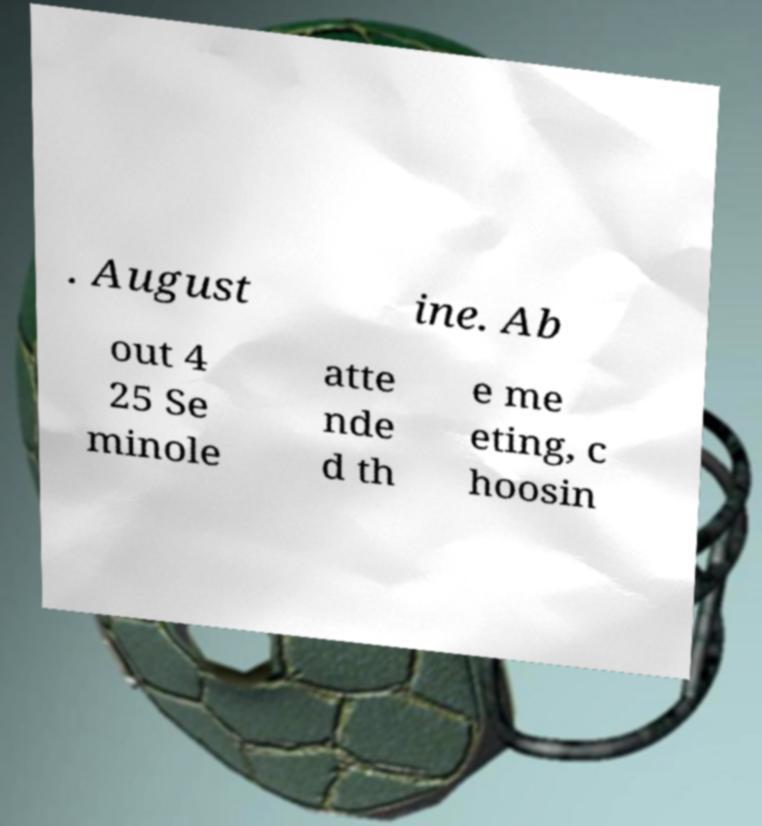There's text embedded in this image that I need extracted. Can you transcribe it verbatim? . August ine. Ab out 4 25 Se minole atte nde d th e me eting, c hoosin 